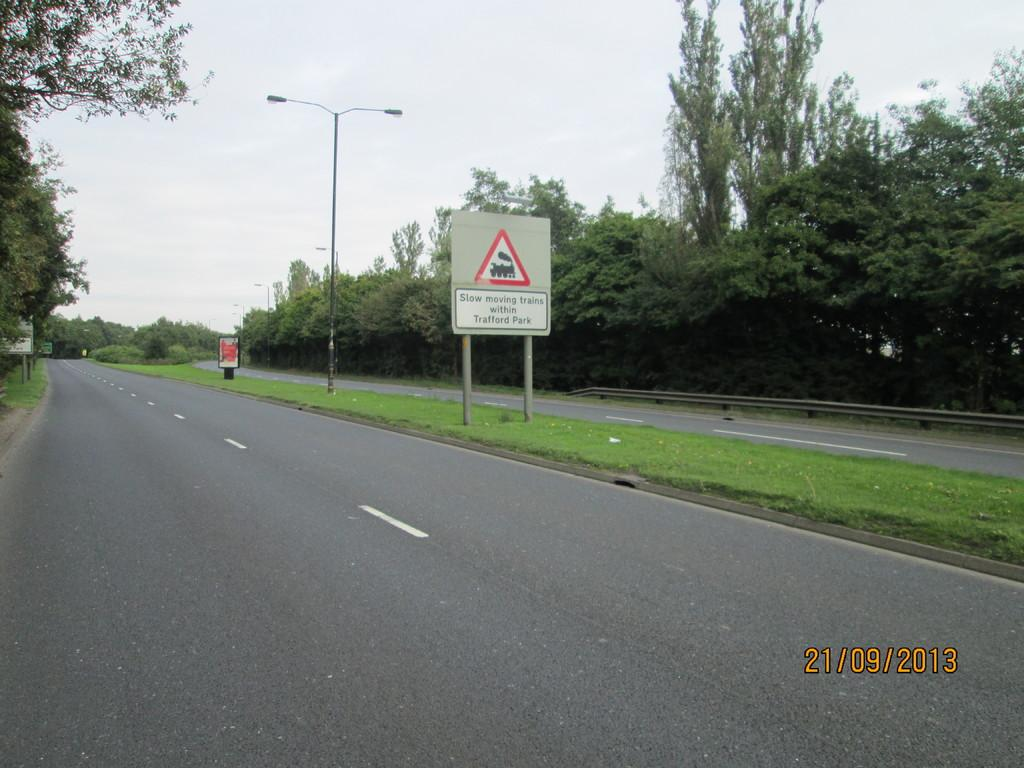<image>
Write a terse but informative summary of the picture. A sign next to a divided highway says, "Slow moving trains within Trafford Park". 